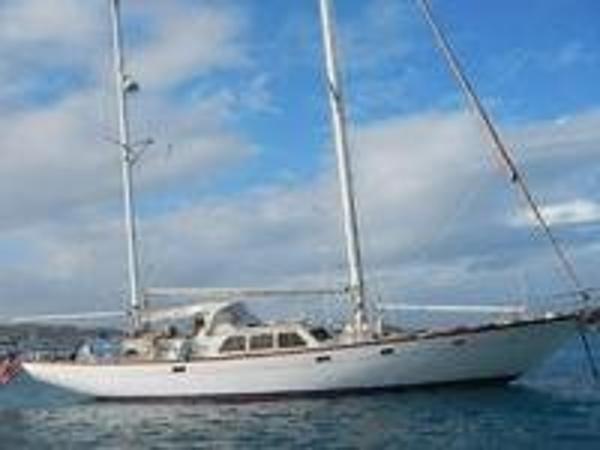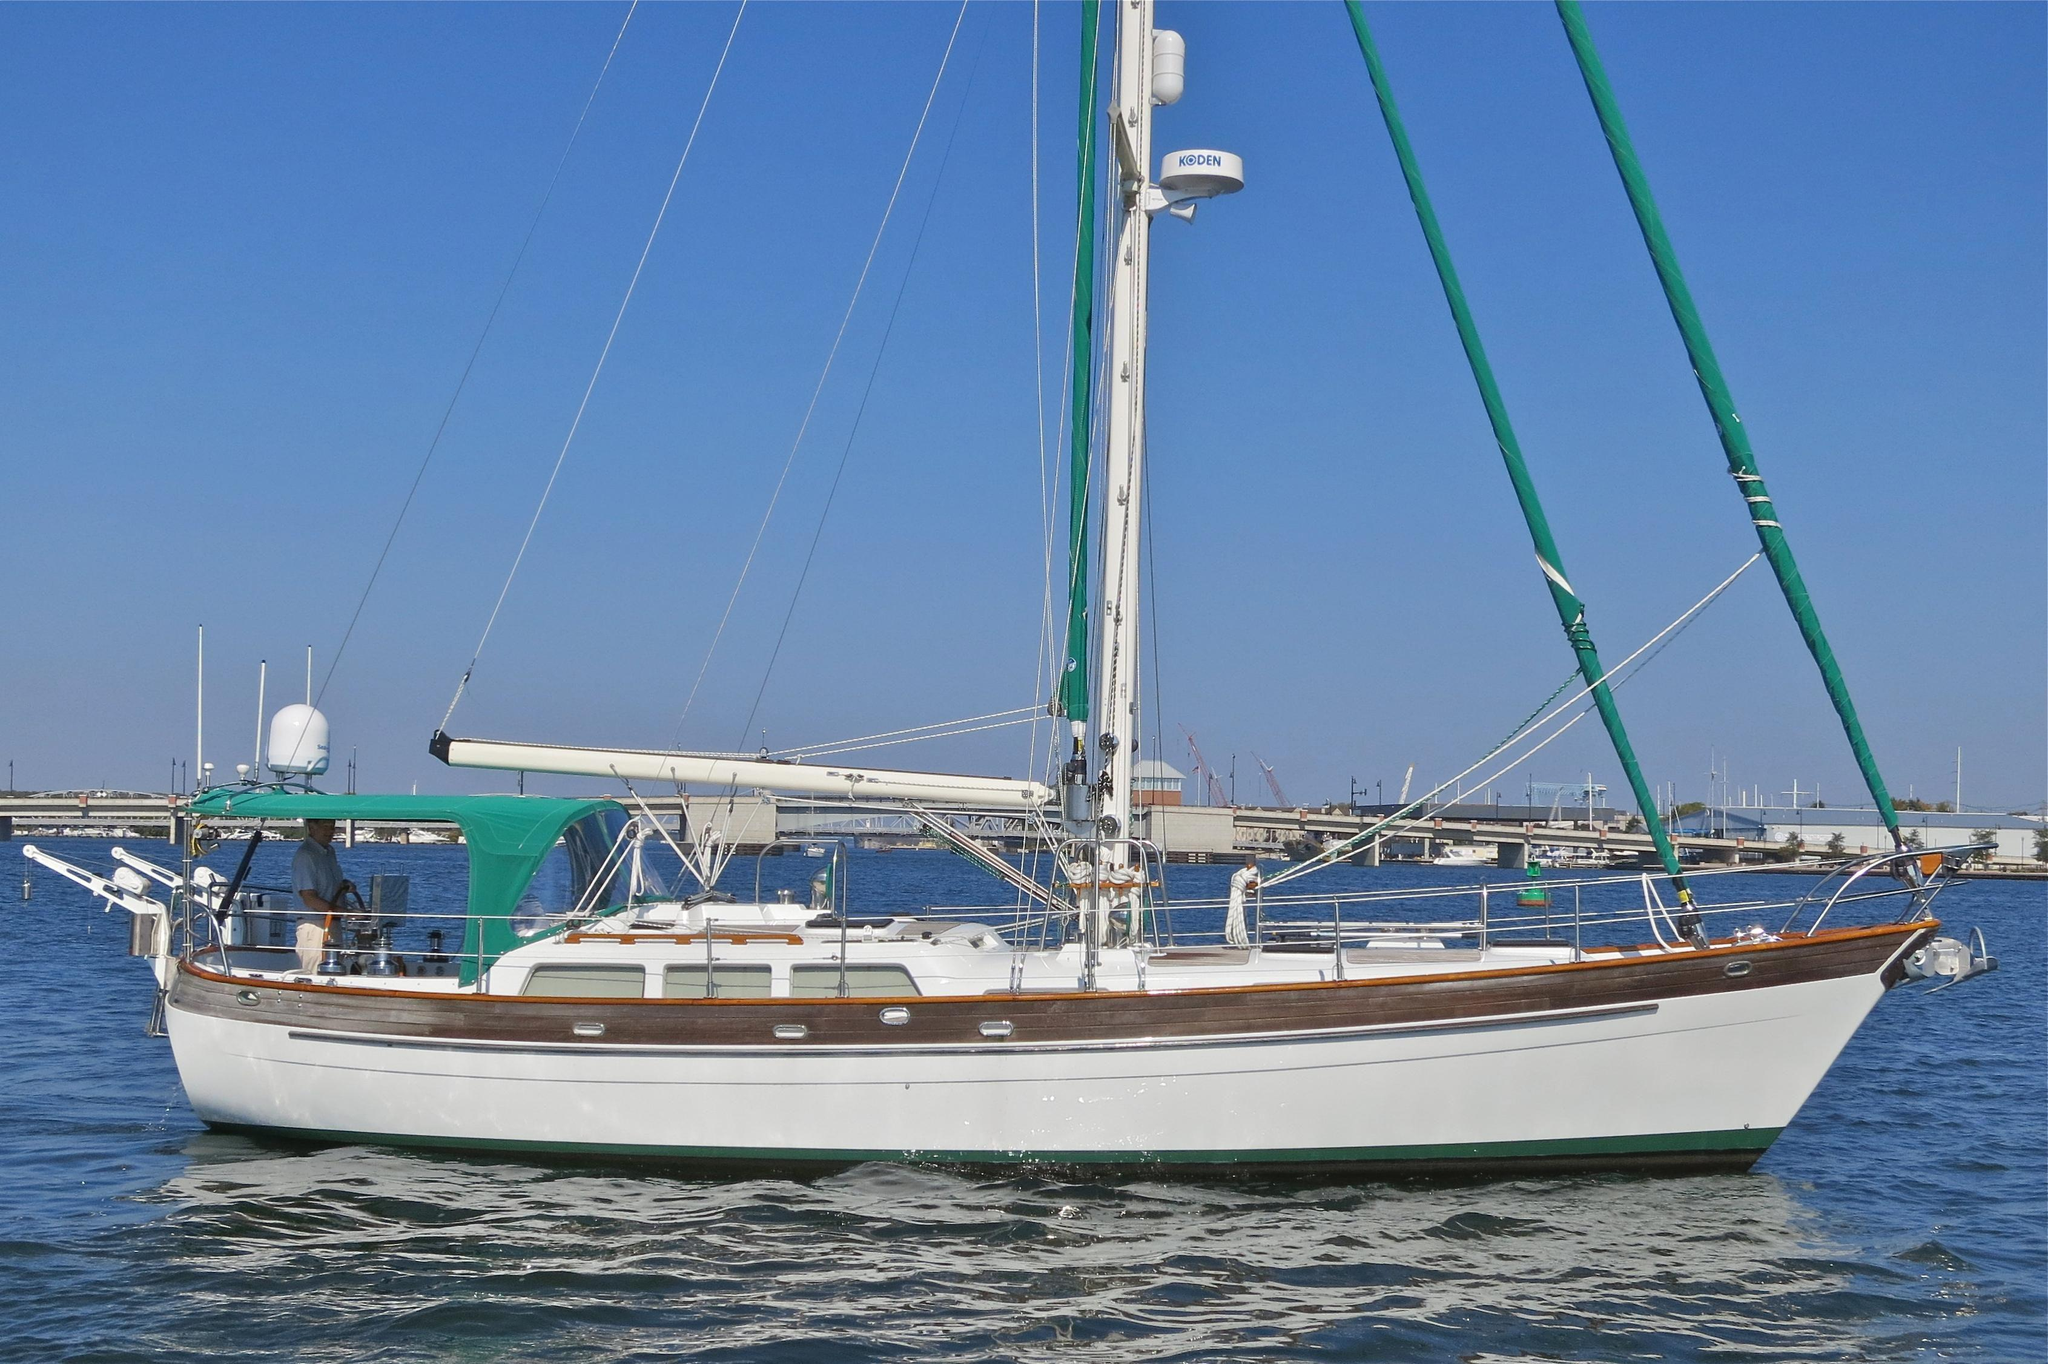The first image is the image on the left, the second image is the image on the right. For the images displayed, is the sentence "There is a ship with at least one sail unfurled." factually correct? Answer yes or no. No. 